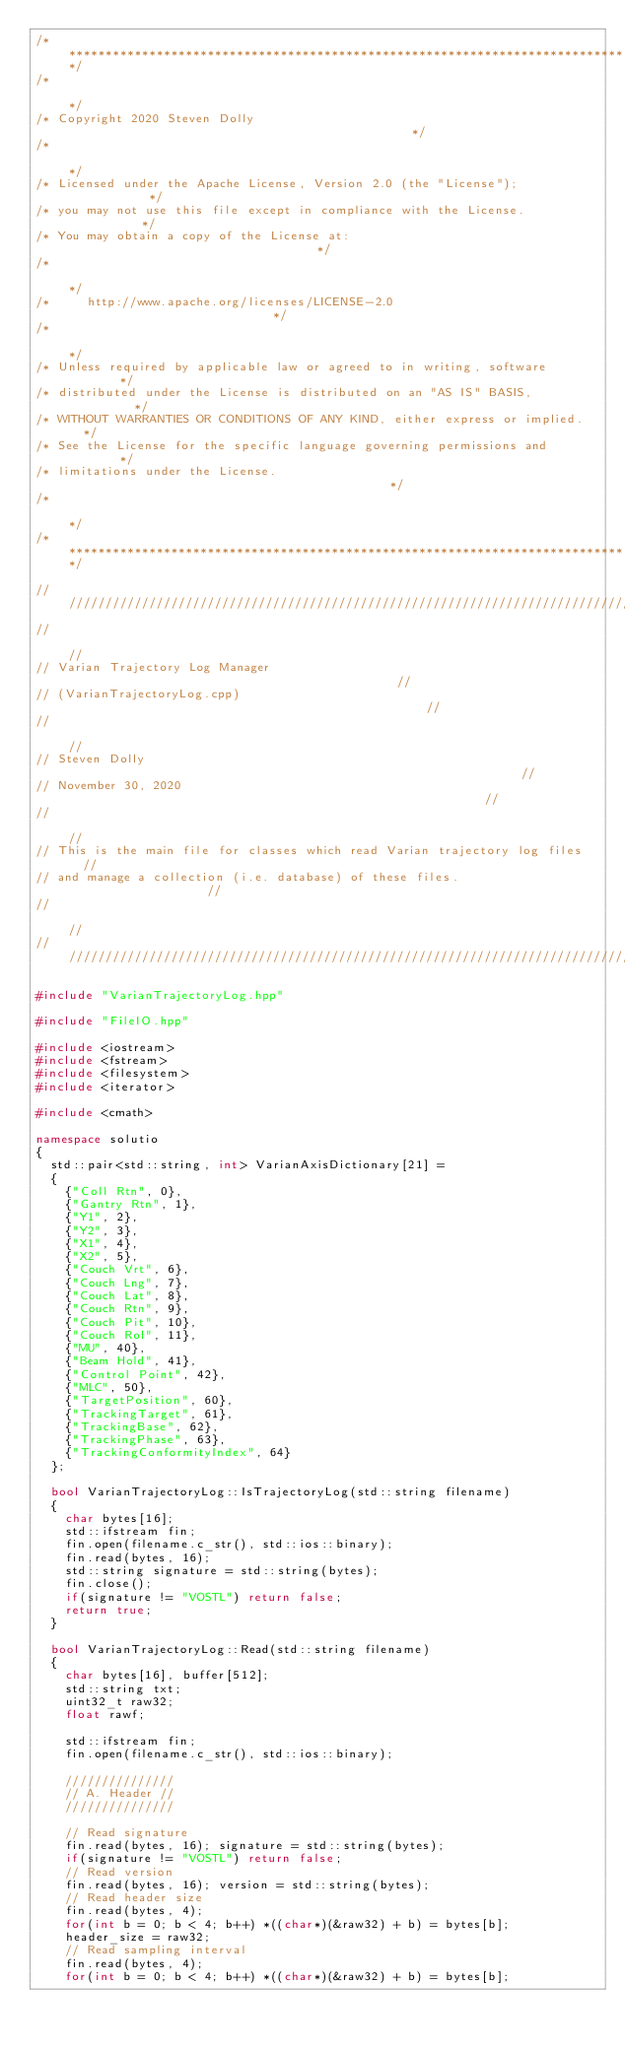Convert code to text. <code><loc_0><loc_0><loc_500><loc_500><_C++_>/******************************************************************************/
/*                                                                            */
/* Copyright 2020 Steven Dolly                                                */
/*                                                                            */
/* Licensed under the Apache License, Version 2.0 (the "License");            */
/* you may not use this file except in compliance with the License.           */
/* You may obtain a copy of the License at:                                   */
/*                                                                            */
/*     http://www.apache.org/licenses/LICENSE-2.0                             */
/*                                                                            */
/* Unless required by applicable law or agreed to in writing, software        */
/* distributed under the License is distributed on an "AS IS" BASIS,          */
/* WITHOUT WARRANTIES OR CONDITIONS OF ANY KIND, either express or implied.   */
/* See the License for the specific language governing permissions and        */
/* limitations under the License.                                             */
/*                                                                            */
/******************************************************************************/

////////////////////////////////////////////////////////////////////////////////
//                                                                            //
// Varian Trajectory Log Manager                                              //
// (VarianTrajectoryLog.cpp)                                                  //
//                                                                            //
// Steven Dolly                                                               //
// November 30, 2020                                                          //
//                                                                            //
// This is the main file for classes which read Varian trajectory log files   //
// and manage a collection (i.e. database) of these files.                    //
//                                                                            //
////////////////////////////////////////////////////////////////////////////////

#include "VarianTrajectoryLog.hpp"

#include "FileIO.hpp"

#include <iostream>
#include <fstream>
#include <filesystem>
#include <iterator>

#include <cmath>

namespace solutio
{
  std::pair<std::string, int> VarianAxisDictionary[21] =
  {
    {"Coll Rtn", 0},
    {"Gantry Rtn", 1},
    {"Y1", 2},
    {"Y2", 3},
    {"X1", 4},
    {"X2", 5},
    {"Couch Vrt", 6},
    {"Couch Lng", 7},
    {"Couch Lat", 8},
    {"Couch Rtn", 9},
    {"Couch Pit", 10},
    {"Couch Rol", 11},
    {"MU", 40},
    {"Beam Hold", 41},
    {"Control Point", 42},
    {"MLC", 50},
    {"TargetPosition", 60},
    {"TrackingTarget", 61},
    {"TrackingBase", 62},
    {"TrackingPhase", 63},
    {"TrackingConformityIndex", 64}
  };

  bool VarianTrajectoryLog::IsTrajectoryLog(std::string filename)
  {
    char bytes[16];
    std::ifstream fin;
    fin.open(filename.c_str(), std::ios::binary);
    fin.read(bytes, 16);
    std::string signature = std::string(bytes);
    fin.close();
    if(signature != "VOSTL") return false;
    return true;
  }

  bool VarianTrajectoryLog::Read(std::string filename)
  {
    char bytes[16], buffer[512];
    std::string txt;
    uint32_t raw32;
    float rawf;

    std::ifstream fin;
    fin.open(filename.c_str(), std::ios::binary);

    ///////////////
    // A. Header //
    ///////////////

    // Read signature
    fin.read(bytes, 16); signature = std::string(bytes);
    if(signature != "VOSTL") return false;
    // Read version
    fin.read(bytes, 16); version = std::string(bytes);
    // Read header size
    fin.read(bytes, 4);
    for(int b = 0; b < 4; b++) *((char*)(&raw32) + b) = bytes[b];
    header_size = raw32;
    // Read sampling interval
    fin.read(bytes, 4);
    for(int b = 0; b < 4; b++) *((char*)(&raw32) + b) = bytes[b];</code> 